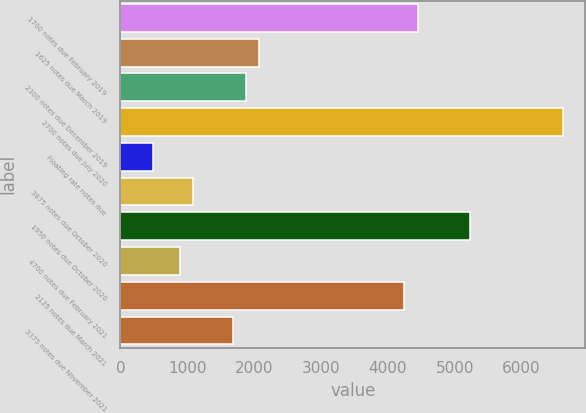Convert chart. <chart><loc_0><loc_0><loc_500><loc_500><bar_chart><fcel>1700 notes due February 2019<fcel>1625 notes due March 2019<fcel>2300 notes due December 2019<fcel>2700 notes due July 2020<fcel>Floating rate notes due<fcel>3875 notes due October 2020<fcel>1950 notes due October 2020<fcel>4700 notes due February 2021<fcel>2125 notes due March 2021<fcel>3375 notes due November 2021<nl><fcel>4443.5<fcel>2073.5<fcel>1876<fcel>6616<fcel>493.5<fcel>1086<fcel>5233.5<fcel>888.5<fcel>4246<fcel>1678.5<nl></chart> 